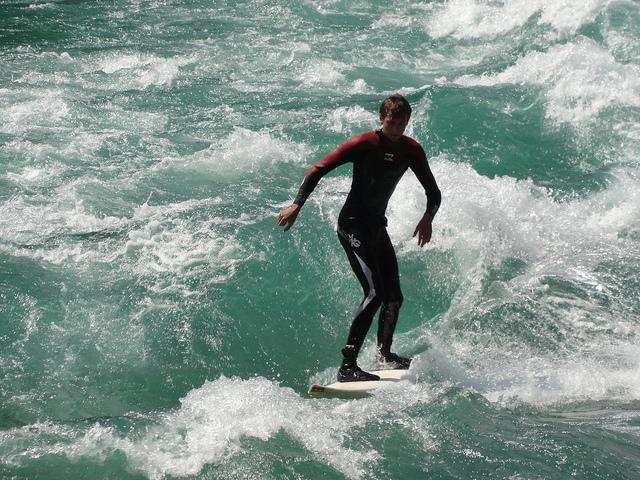How many surfers in the water?
Give a very brief answer. 1. 